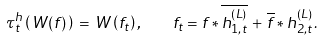Convert formula to latex. <formula><loc_0><loc_0><loc_500><loc_500>\tau _ { t } ^ { h } \left ( \, W ( f ) \, \right ) \, = \, W \left ( f _ { t } \right ) , \quad f _ { t } = f * \overline { h ^ { ( L ) } _ { 1 , t } } \, + \, \overline { f } * h ^ { ( L ) } _ { 2 , t } \, .</formula> 